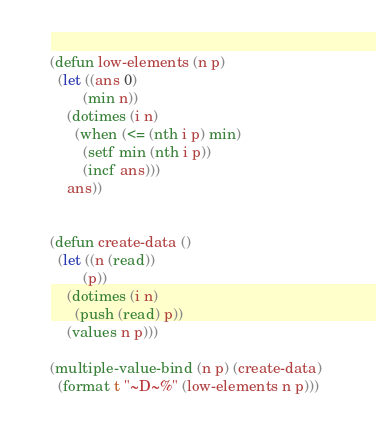<code> <loc_0><loc_0><loc_500><loc_500><_Lisp_>(defun low-elements (n p)
  (let ((ans 0) 
        (min n)) 
    (dotimes (i n) 
      (when (<= (nth i p) min)
        (setf min (nth i p)) 
        (incf ans)))
    ans)) 


(defun create-data ()
  (let ((n (read))
        (p))
    (dotimes (i n)
      (push (read) p))
    (values n p))) 

(multiple-value-bind (n p) (create-data) 
  (format t "~D~%" (low-elements n p))) 

</code> 